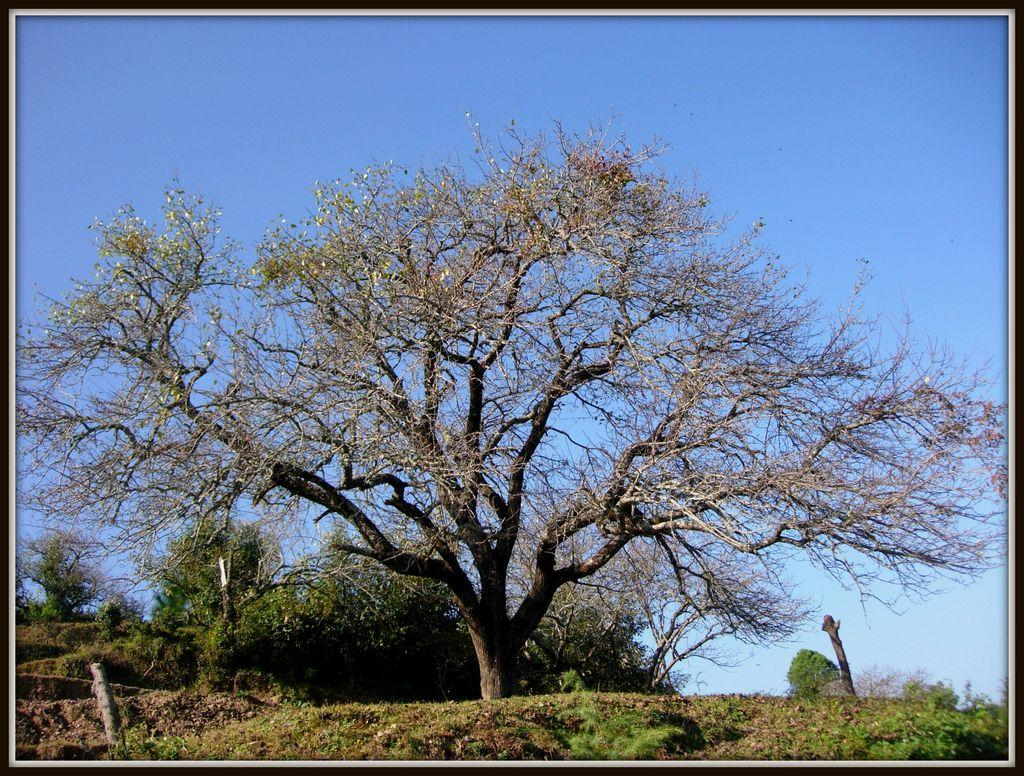What type of vegetation can be seen in the image? There is a group of trees, plants, and grass in the image. What else can be seen in the image besides vegetation? There are wooden poles in the image. What is visible in the background of the image? The sky is visible in the image. How would you describe the sky in the image? The sky appears to be cloudy in the image. What type of magic is being performed in the image? There is no magic or performance present in the image; it features a group of trees, plants, grass, wooden poles, and a cloudy sky. 